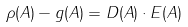<formula> <loc_0><loc_0><loc_500><loc_500>\rho ( A ) - g ( A ) = D ( A ) \cdot E ( A )</formula> 